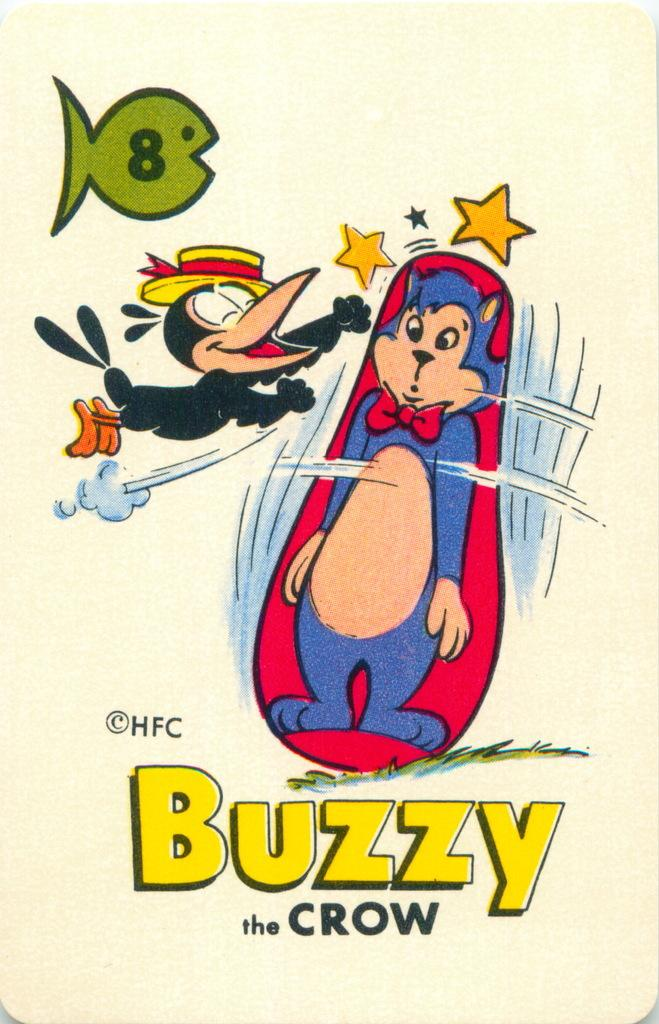<image>
Render a clear and concise summary of the photo. A cartoon picture of a Buzzy the crow punching a punching bag with a picture of a cat on it. 